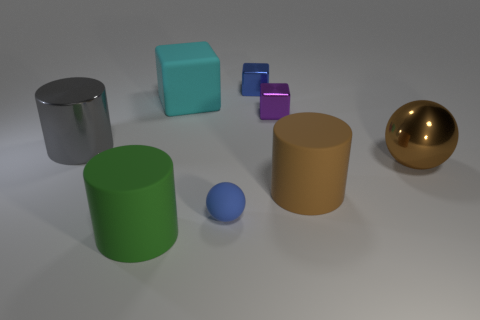Add 2 big cyan rubber objects. How many objects exist? 10 Subtract 1 cylinders. How many cylinders are left? 2 Subtract all cylinders. How many objects are left? 5 Subtract 0 brown blocks. How many objects are left? 8 Subtract all big cyan matte balls. Subtract all cylinders. How many objects are left? 5 Add 3 small blocks. How many small blocks are left? 5 Add 1 tiny green shiny spheres. How many tiny green shiny spheres exist? 1 